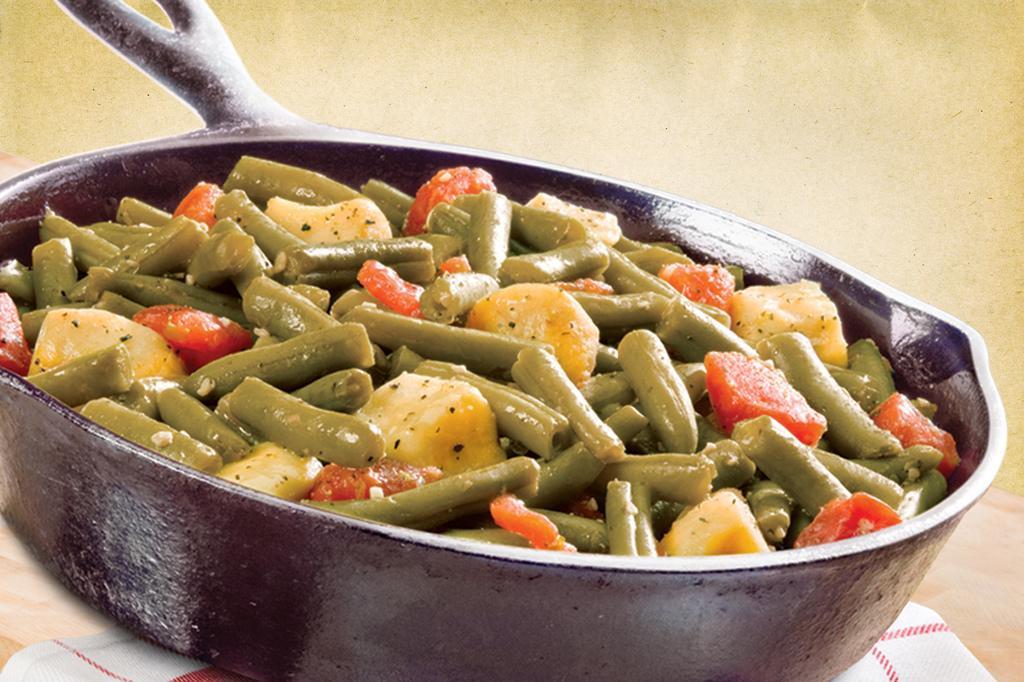Can you describe this image briefly? Here in this picture we can see fried vegetable present in a pan, which is present on the table over there and we can also see cloth present below it over there. 